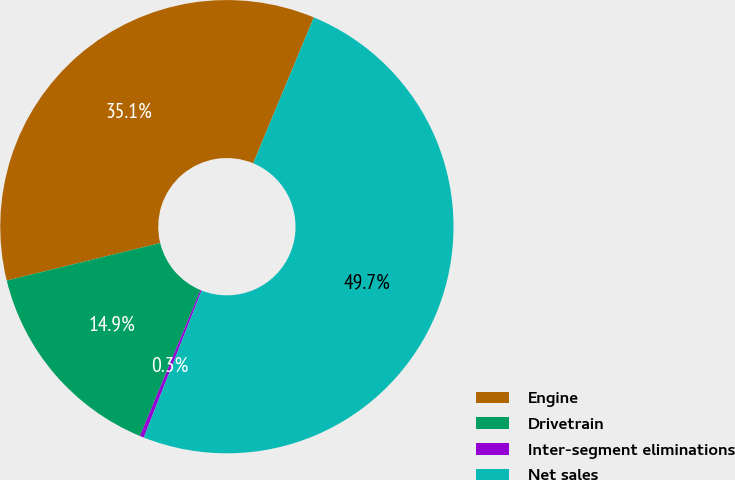Convert chart to OTSL. <chart><loc_0><loc_0><loc_500><loc_500><pie_chart><fcel>Engine<fcel>Drivetrain<fcel>Inter-segment eliminations<fcel>Net sales<nl><fcel>35.09%<fcel>14.91%<fcel>0.29%<fcel>49.71%<nl></chart> 